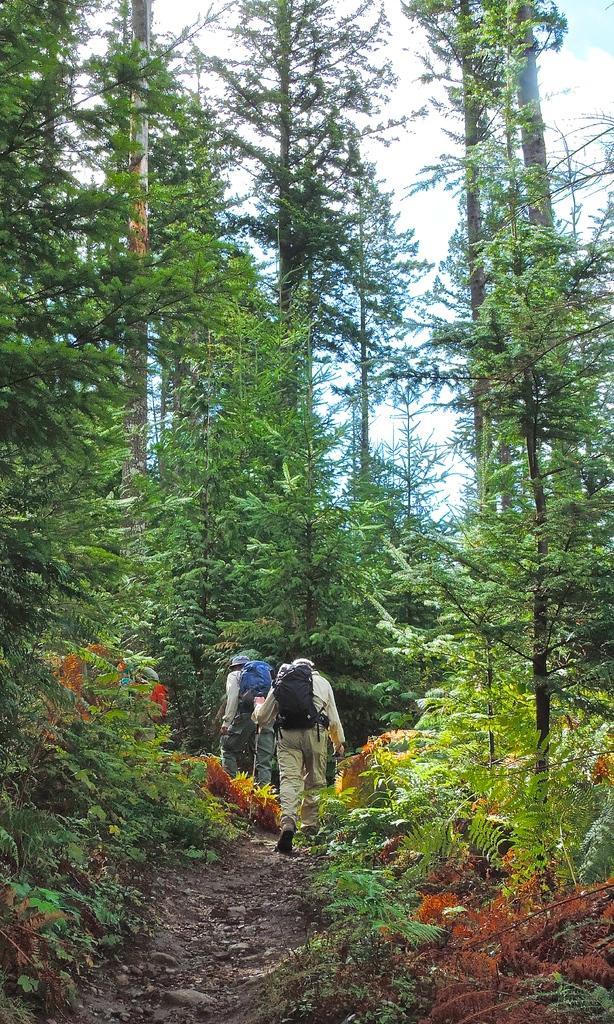How would you summarize this image in a sentence or two? In this image I can see trees, plant and people walking on the ground. These people are carrying bags. In the background I can see the sky. 